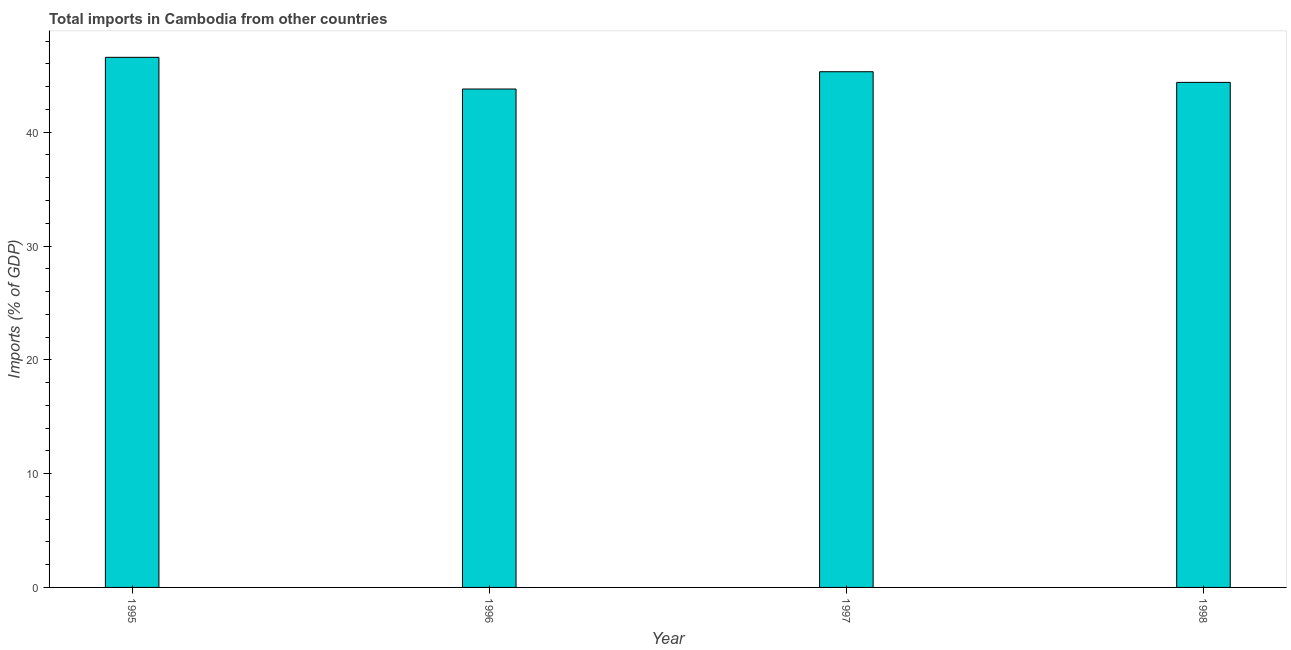Does the graph contain any zero values?
Offer a terse response. No. Does the graph contain grids?
Provide a succinct answer. No. What is the title of the graph?
Your answer should be very brief. Total imports in Cambodia from other countries. What is the label or title of the X-axis?
Offer a terse response. Year. What is the label or title of the Y-axis?
Your answer should be compact. Imports (% of GDP). What is the total imports in 1996?
Give a very brief answer. 43.8. Across all years, what is the maximum total imports?
Offer a terse response. 46.58. Across all years, what is the minimum total imports?
Your answer should be compact. 43.8. In which year was the total imports minimum?
Provide a short and direct response. 1996. What is the sum of the total imports?
Give a very brief answer. 180.08. What is the difference between the total imports in 1995 and 1998?
Give a very brief answer. 2.2. What is the average total imports per year?
Provide a succinct answer. 45.02. What is the median total imports?
Offer a terse response. 44.85. Do a majority of the years between 1995 and 1996 (inclusive) have total imports greater than 16 %?
Offer a terse response. Yes. What is the ratio of the total imports in 1995 to that in 1998?
Offer a very short reply. 1.05. Is the total imports in 1996 less than that in 1997?
Offer a very short reply. Yes. What is the difference between the highest and the second highest total imports?
Provide a short and direct response. 1.26. Is the sum of the total imports in 1995 and 1996 greater than the maximum total imports across all years?
Offer a terse response. Yes. What is the difference between the highest and the lowest total imports?
Make the answer very short. 2.78. Are all the bars in the graph horizontal?
Your answer should be very brief. No. What is the Imports (% of GDP) in 1995?
Provide a succinct answer. 46.58. What is the Imports (% of GDP) of 1996?
Provide a short and direct response. 43.8. What is the Imports (% of GDP) of 1997?
Give a very brief answer. 45.32. What is the Imports (% of GDP) of 1998?
Your response must be concise. 44.38. What is the difference between the Imports (% of GDP) in 1995 and 1996?
Provide a short and direct response. 2.78. What is the difference between the Imports (% of GDP) in 1995 and 1997?
Keep it short and to the point. 1.26. What is the difference between the Imports (% of GDP) in 1995 and 1998?
Offer a very short reply. 2.2. What is the difference between the Imports (% of GDP) in 1996 and 1997?
Ensure brevity in your answer.  -1.52. What is the difference between the Imports (% of GDP) in 1996 and 1998?
Provide a short and direct response. -0.58. What is the difference between the Imports (% of GDP) in 1997 and 1998?
Your answer should be compact. 0.94. What is the ratio of the Imports (% of GDP) in 1995 to that in 1996?
Ensure brevity in your answer.  1.06. What is the ratio of the Imports (% of GDP) in 1995 to that in 1997?
Your answer should be compact. 1.03. What is the ratio of the Imports (% of GDP) in 1995 to that in 1998?
Make the answer very short. 1.05. 